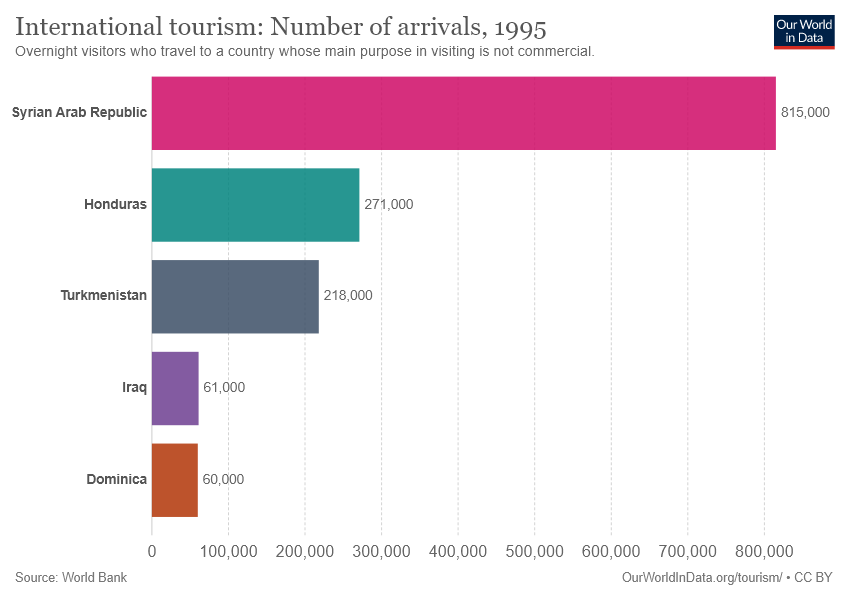Outline some significant characteristics in this image. There are five bars in the graph. The total sum of Dominica and Iraq is 121000. 